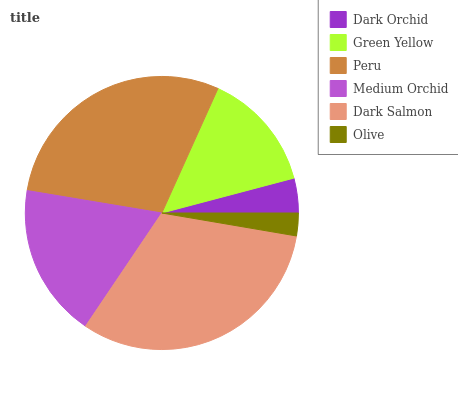Is Olive the minimum?
Answer yes or no. Yes. Is Dark Salmon the maximum?
Answer yes or no. Yes. Is Green Yellow the minimum?
Answer yes or no. No. Is Green Yellow the maximum?
Answer yes or no. No. Is Green Yellow greater than Dark Orchid?
Answer yes or no. Yes. Is Dark Orchid less than Green Yellow?
Answer yes or no. Yes. Is Dark Orchid greater than Green Yellow?
Answer yes or no. No. Is Green Yellow less than Dark Orchid?
Answer yes or no. No. Is Medium Orchid the high median?
Answer yes or no. Yes. Is Green Yellow the low median?
Answer yes or no. Yes. Is Green Yellow the high median?
Answer yes or no. No. Is Peru the low median?
Answer yes or no. No. 